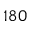Convert formula to latex. <formula><loc_0><loc_0><loc_500><loc_500>1 8 0</formula> 